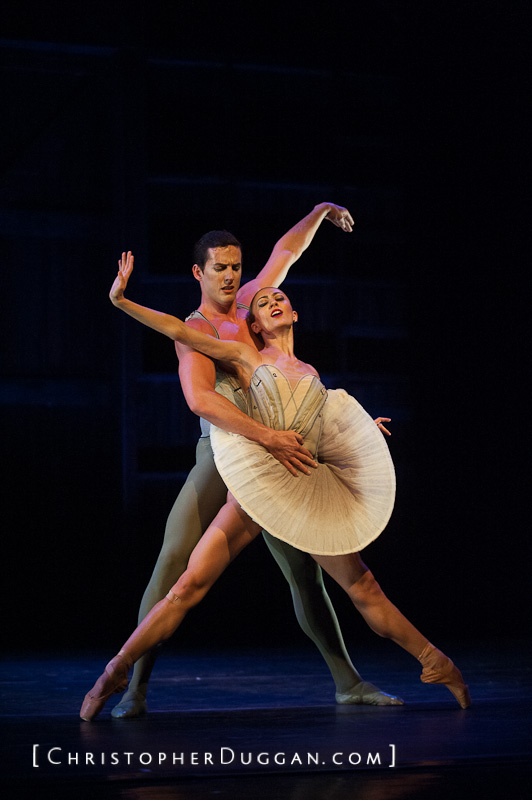If these dancers were characters in a fantastical story, what might their magical abilities be? In a fantastical story, these dancers could possess enchanting magical abilities that mirror their grace and connection. The male dancer might wield the power of shadow manipulation, able to create protective shadows that dance with him, providing safety and tranquility. His shadows could guide lost souls or create illusions to mesmerize enemies. The female dancer, on the other hand, could possess the power of light and air. She could summon gentle breezes to lift and float effortlessly or emit beams of light to heal and inspire those around her. Together, their combination of shadows and light, air and earth, would allow them to perform mesmerizing dances that weave magic and emotion, casting spells of wonder and enchantment on their audience. Describe a realistic scenario where their dance could deeply move an audience. Imagine a grand theater filled with an audience who has gathered for a special evening performance dedicated to the memory of a beloved local artist. As the curtains rise, these dancers begin their elegant routine, their movements perfectly synchronized and full of emotion. The male dancer’s supportive hold and the female dancer’s graceful arcs and lifts tell a poignant story of a couple’s enduring love through trials and triumphs. Every extension of the arm and graceful lift is imbued with sorrow, joy, and hope. By the end of the performance, the audience is left in tears, moved by the profound narrative of love and loss, evoked solely through the dancers' expressive choreography and emotive expressions. 